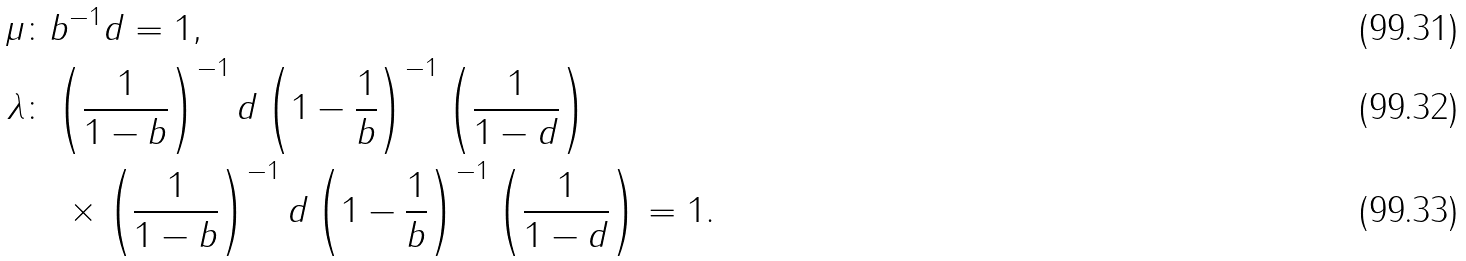<formula> <loc_0><loc_0><loc_500><loc_500>\mu & \colon b ^ { - 1 } d = 1 , \\ \lambda & \colon \left ( \frac { 1 } { 1 - b } \right ) ^ { - 1 } d \left ( 1 - \frac { 1 } { b } \right ) ^ { - 1 } \left ( \frac { 1 } { 1 - d } \right ) \\ & \quad \times \left ( \frac { 1 } { 1 - b } \right ) ^ { - 1 } d \left ( 1 - \frac { 1 } { b } \right ) ^ { - 1 } \left ( \frac { 1 } { 1 - d } \right ) = 1 .</formula> 